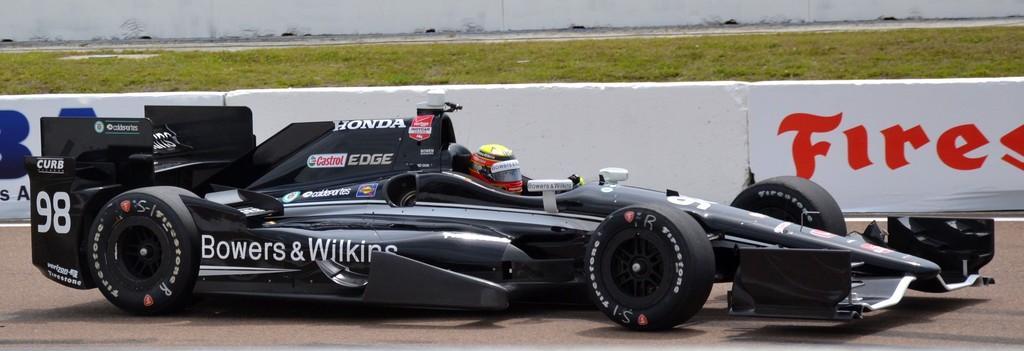Please provide a concise description of this image. In this image, It looks like an auto racing car, which is black in color. I can see a person sitting in the car with a helmet. I think this is a wall with the letters written on it. At the top of the image, I can see the grass. 